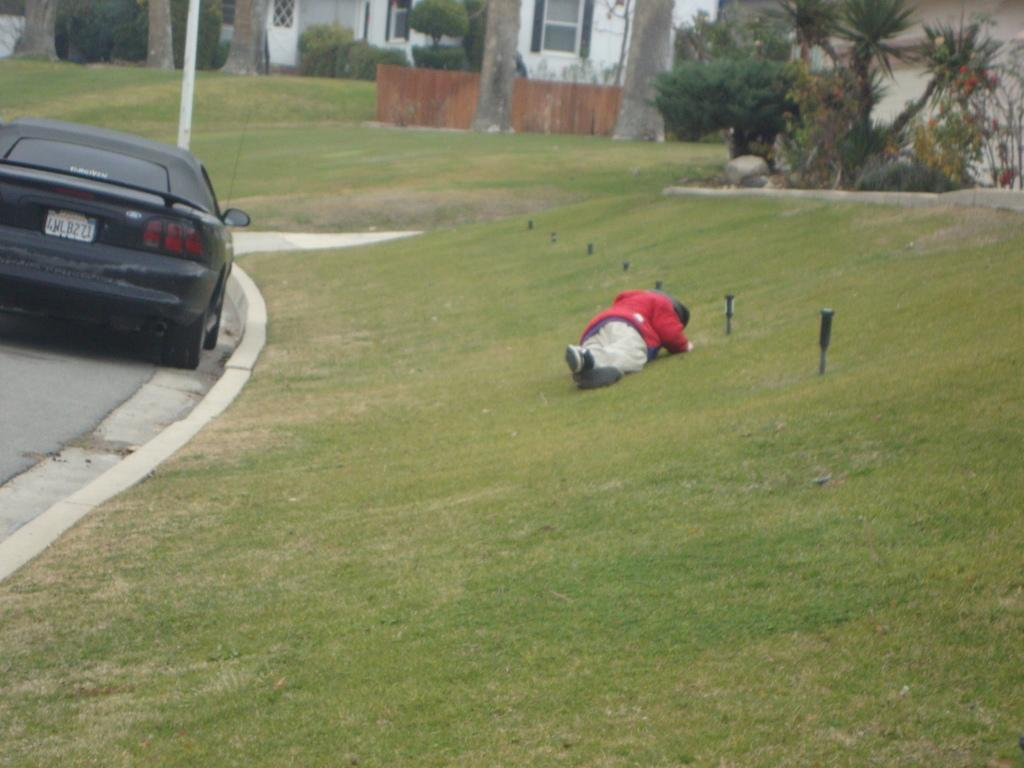What is the person in the image doing? The person is lying on the grass. What can be seen on the road in the image? There is a car on the road. What is visible in the background of the image? Trees, buildings, and a pole are visible in the background. What type of thread is being used to hold the plants together in the image? There are no plants present in the image, so there is no thread being used to hold them together. 